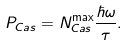Convert formula to latex. <formula><loc_0><loc_0><loc_500><loc_500>P _ { C a s } = N _ { C a s } ^ { \max } \frac { \hbar { \omega } } { \tau } .</formula> 